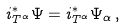Convert formula to latex. <formula><loc_0><loc_0><loc_500><loc_500>i _ { T ^ { \alpha } } ^ { * } \Psi = i _ { T ^ { \alpha } } ^ { * } \Psi _ { \alpha } \, ,</formula> 